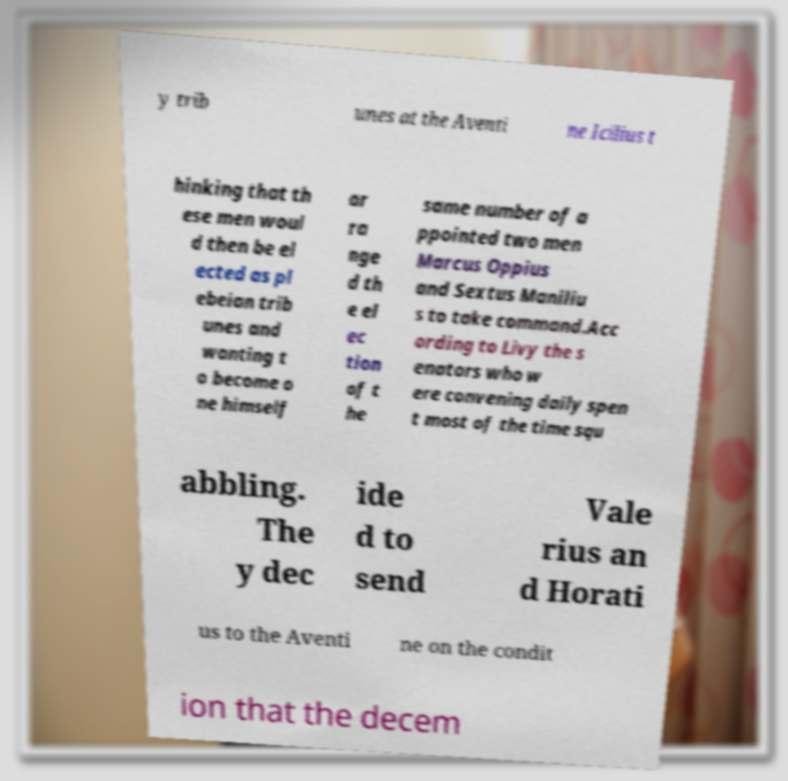For documentation purposes, I need the text within this image transcribed. Could you provide that? y trib unes at the Aventi ne Icilius t hinking that th ese men woul d then be el ected as pl ebeian trib unes and wanting t o become o ne himself ar ra nge d th e el ec tion of t he same number of a ppointed two men Marcus Oppius and Sextus Maniliu s to take command.Acc ording to Livy the s enators who w ere convening daily spen t most of the time squ abbling. The y dec ide d to send Vale rius an d Horati us to the Aventi ne on the condit ion that the decem 